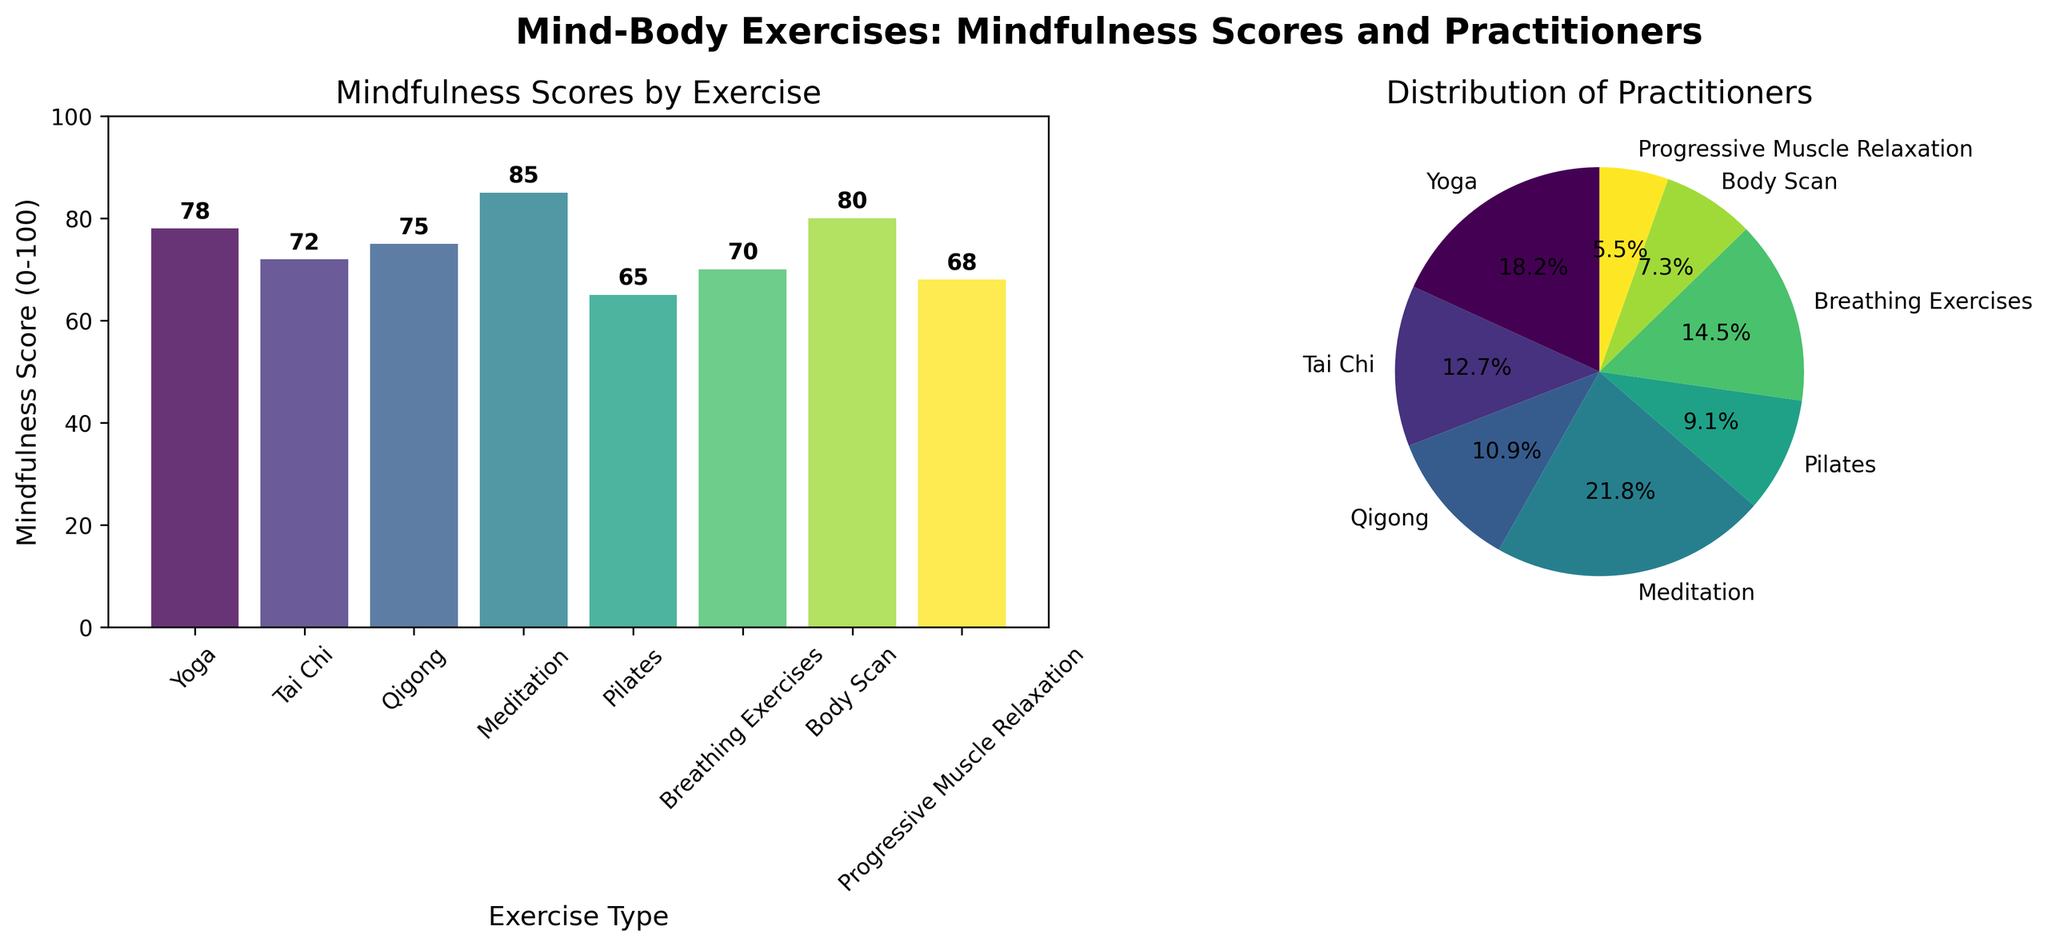What are the mindfulness scores for Yoga and Qigong? The bar chart shows the mindfulness scores. By looking at the heights of the bars labeled "Yoga" and "Qigong", we find Yoga has a mindfulness score of 78 and Qigong has 75.
Answer: Yoga: 78, Qigong: 75 Which exercise has the highest mindfulness score? The highest mindfulness score can be found by identifying the tallest bar in the bar chart. The tallest bar is labeled "Meditation" with a score of 85.
Answer: Meditation How many practitioners engage in Progressive Muscle Relaxation? The distribution of practitioners is shown in the pie chart. By locating the segment labeled "Progressive Muscle Relaxation," we can see it represents 150 practitioners.
Answer: 150 What is the difference in mindfulness scores between Meditation and Pilates? First, identify the mindfulness scores for Meditation (85) and Pilates (65) from the bar chart. Then calculate the difference: 85 - 65 = 20.
Answer: 20 Which exercise has the fewest practitioners? The fewest practitioners can be found by looking at the smallest segment in the pie chart. The smallest segment is labeled "Progressive Muscle Relaxation" which represents 150 practitioners.
Answer: Progressive Muscle Relaxation What is the average mindfulness score for Yoga, Tai Chi, and Qigong? First, identify the mindfulness scores: Yoga (78), Tai Chi (72), and Qigong (75). Sum these scores: 78 + 72 + 75 = 225. Then, divide by the number of exercises: 225 / 3 = 75.
Answer: 75 Is the mindfulness score of Breathing Exercises greater than that of Tai Chi? By comparing the bars, Breathing Exercises have a score of 70 and Tai Chi has a score of 72. Since 70 is less than 72, Breathing Exercises' score is not greater than that of Tai Chi.
Answer: No What proportion of practitioners engage in Yoga relative to the total number of practitioners? First, find the total number of practitioners by summing all the given values: 500 + 350 + 300 + 600 + 250 + 400 + 200 + 150 = 2750. Then, divide the number of Yoga practitioners (500) by the total: 500 / 2750 ≈ 0.18, or 18%.
Answer: 18% Which has a lower mindfulness score: Body Scan or Breathing Exercises? Comparing the bars, Body Scan has a mindfulness score of 80, and Breathing Exercises have 70. Therefore, Breathing Exercises have the lower score.
Answer: Breathing Exercises Which exercise type has the second highest number of practitioners? Identify the slice sizes in the pie chart: the largest (Meditation: 600), second largest can be identified as Breathing Exercises with 400 practitioners.
Answer: Breathing Exercises 